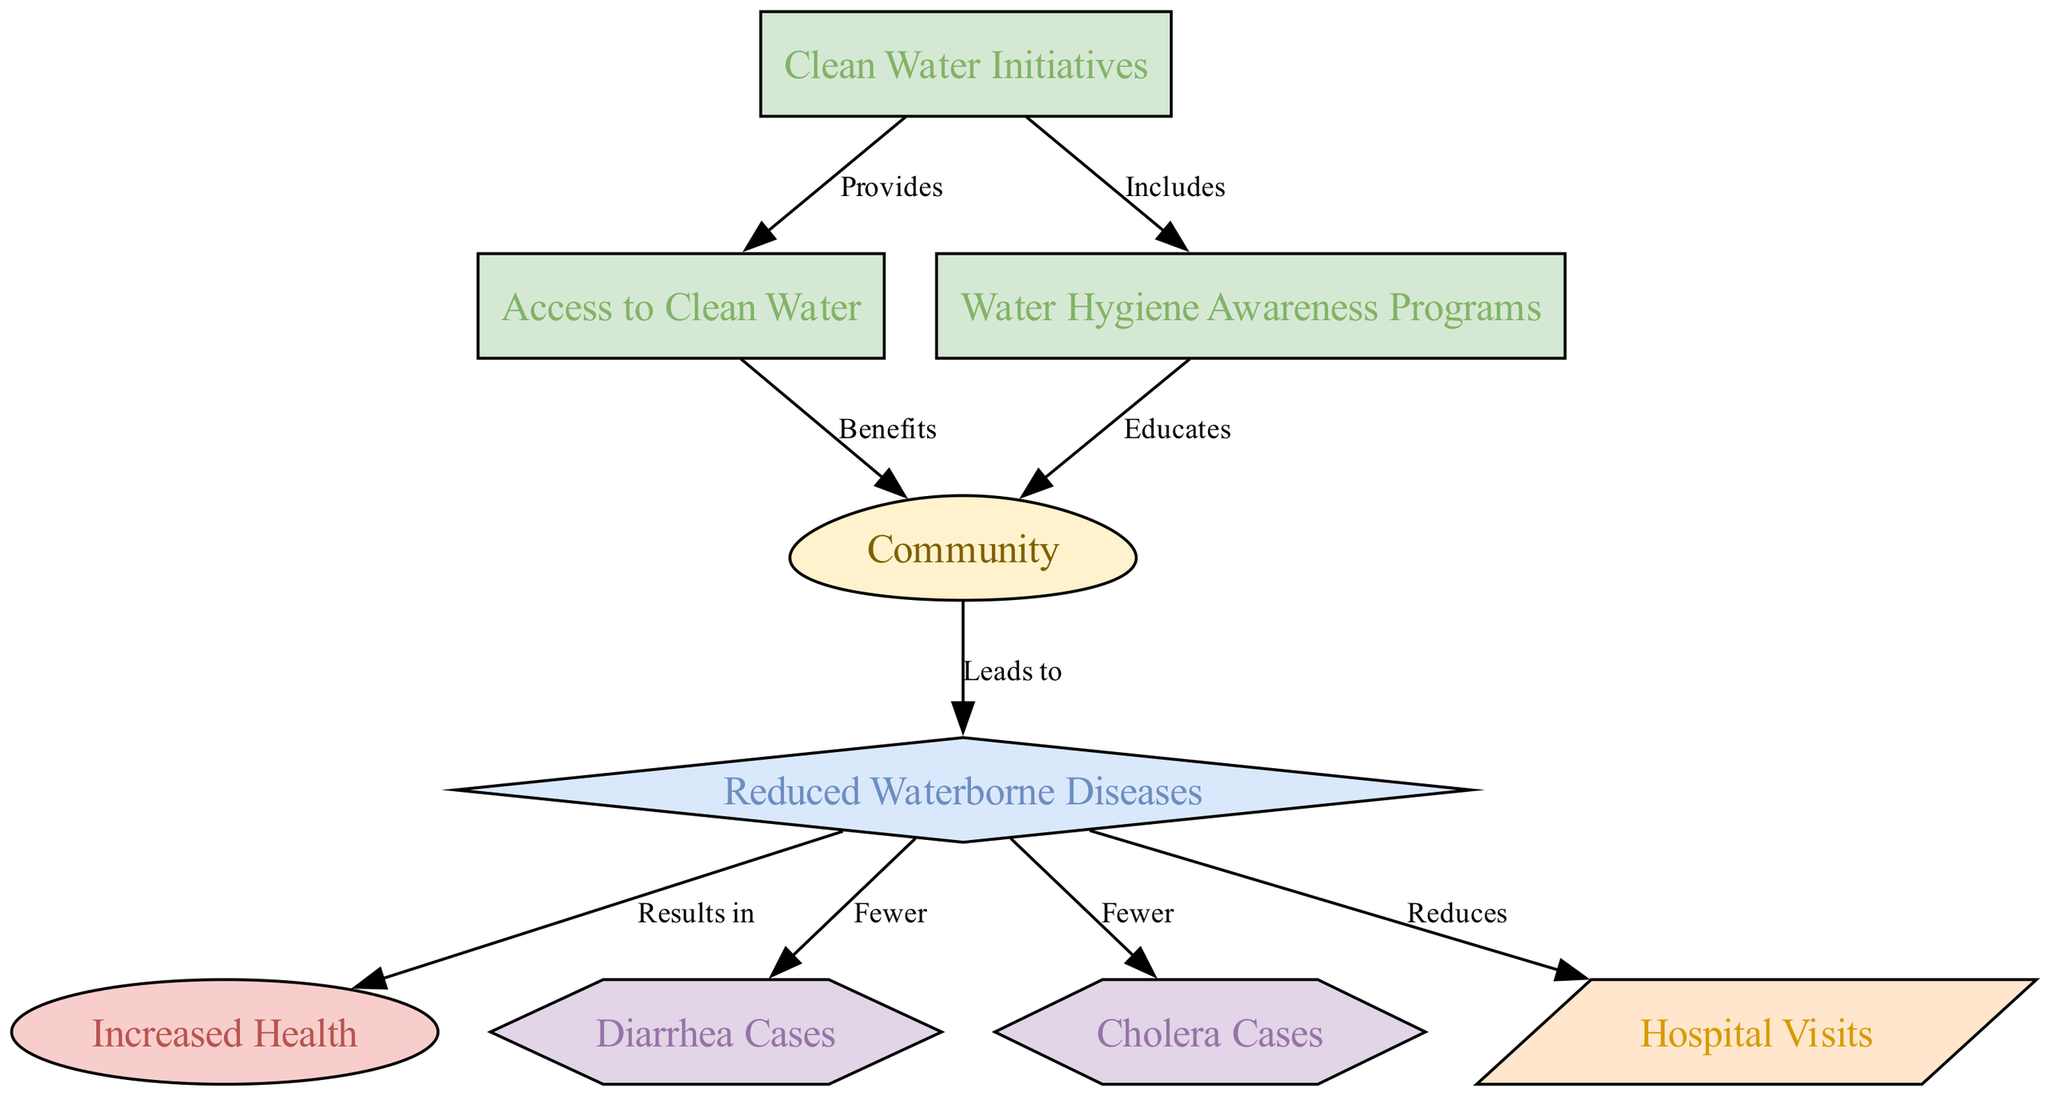What does "Clean Water Initiatives" provide to the "Access to Clean Water"? The edge labeled "Provides" between the nodes "Clean Water Initiatives" and "Access to Clean Water" indicates that clean water initiatives are aimed at providing access to clean water.
Answer: Provides What is the relationship between "Community" and "Reduced Waterborne Diseases"? The edge labeled "Leads to" between "Community" and "Reduced Waterborne Diseases" means that the community's actions or changes contribute to a reduction in waterborne diseases.
Answer: Leads to How many nodes are present in the diagram? By counting the nodes listed in the data, we find there are eight nodes in total: Community, Clean Water Initiatives, Reduced Waterborne Diseases, Increased Health, Diarrhea Cases, Cholera Cases, Hospital Visits, Access to Clean Water, and Water Hygiene Awareness Programs.
Answer: Eight What is the label of the edge connecting "Reduced Waterborne Diseases" to "Increased Health"? The connection is represented by an edge labeled "Results in," showing that a reduction in waterborne diseases leads to increased health outcomes for the community.
Answer: Results in How does "Water Hygiene Awareness Programs" affect the "Community"? The edge labeled "Educates" indicates that water hygiene awareness programs aim to educate the community about proper water use and hygiene practices.
Answer: Educates What type of nodes are "Diarrhea Cases" and "Cholera Cases"? Both "Diarrhea Cases" and "Cholera Cases" are represented as hexagonal shapes in the diagram, indicating they are part of the same category or type of information relating to health consequences of waterborne diseases.
Answer: Hexagons What is the consequence of "Reduced Waterborne Diseases" on "Hospital Visits"? The edge labeled "Reduces" shows that a decrease in the incidence of waterborne diseases leads to fewer hospital visits, indicating an overall improvement in community health.
Answer: Reduces What kind of programs are included under "Clean Water Initiatives"? The edge labeled "Includes" leads to "Water Hygiene Awareness Programs," showing that clean water initiatives encompass educational programs focused on hygiene practices.
Answer: Includes How many edges are there in the diagram? By counting the edges listed in the data, we find that there are nine edges connecting the various nodes in the diagram.
Answer: Nine 